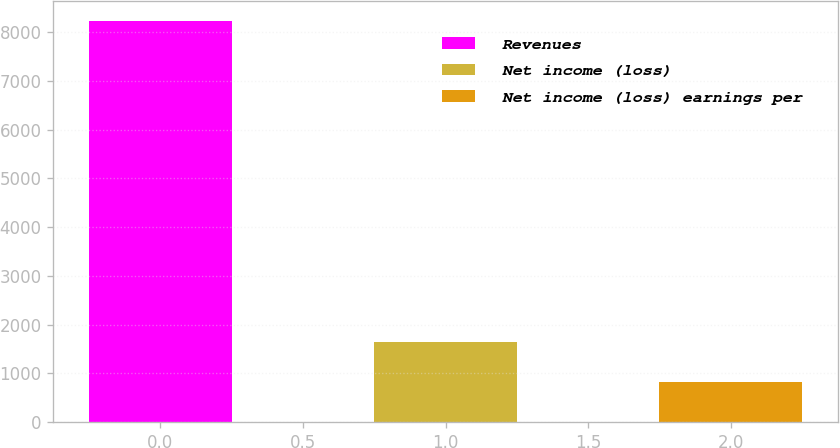<chart> <loc_0><loc_0><loc_500><loc_500><bar_chart><fcel>Revenues<fcel>Net income (loss)<fcel>Net income (loss) earnings per<nl><fcel>8242<fcel>1648.68<fcel>824.51<nl></chart> 